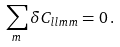<formula> <loc_0><loc_0><loc_500><loc_500>\sum _ { m } \delta C _ { l l m m } = 0 \, .</formula> 